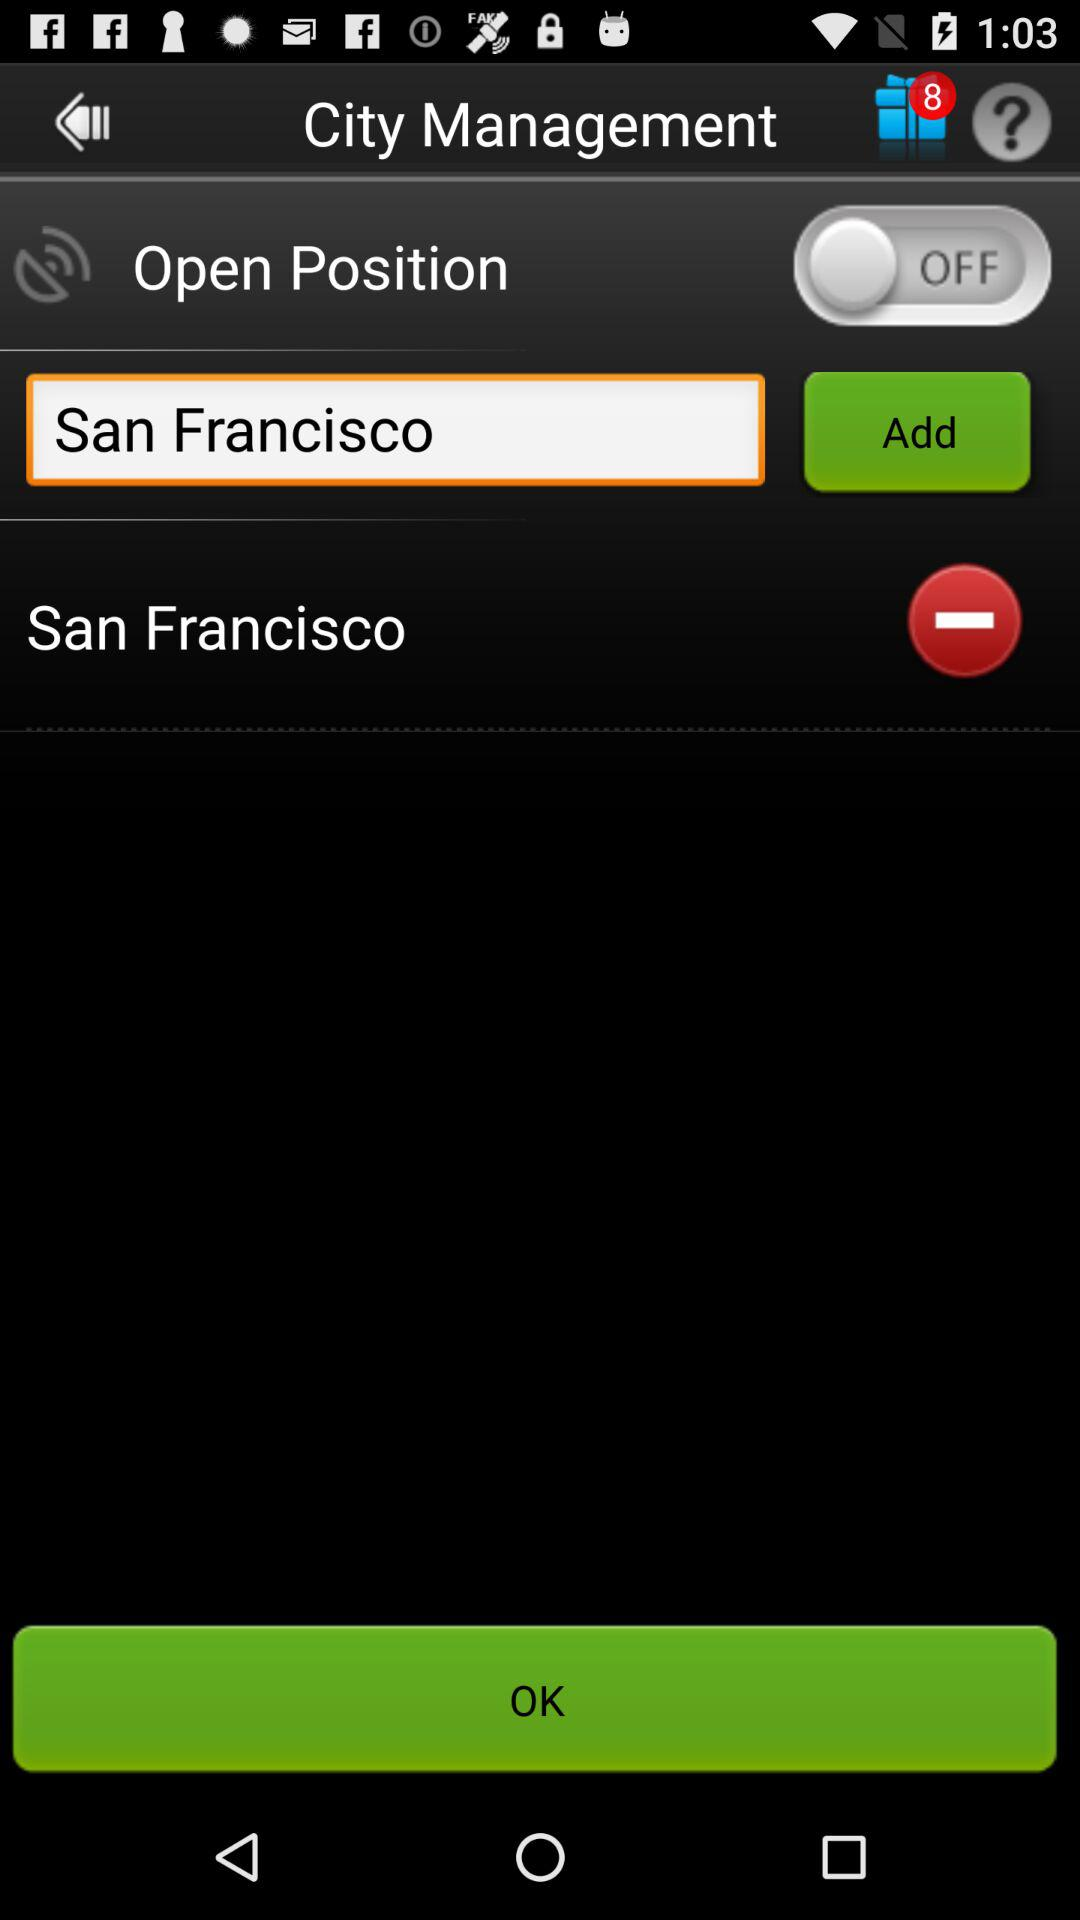What is the status of the "Open Position"? The status is "off". 